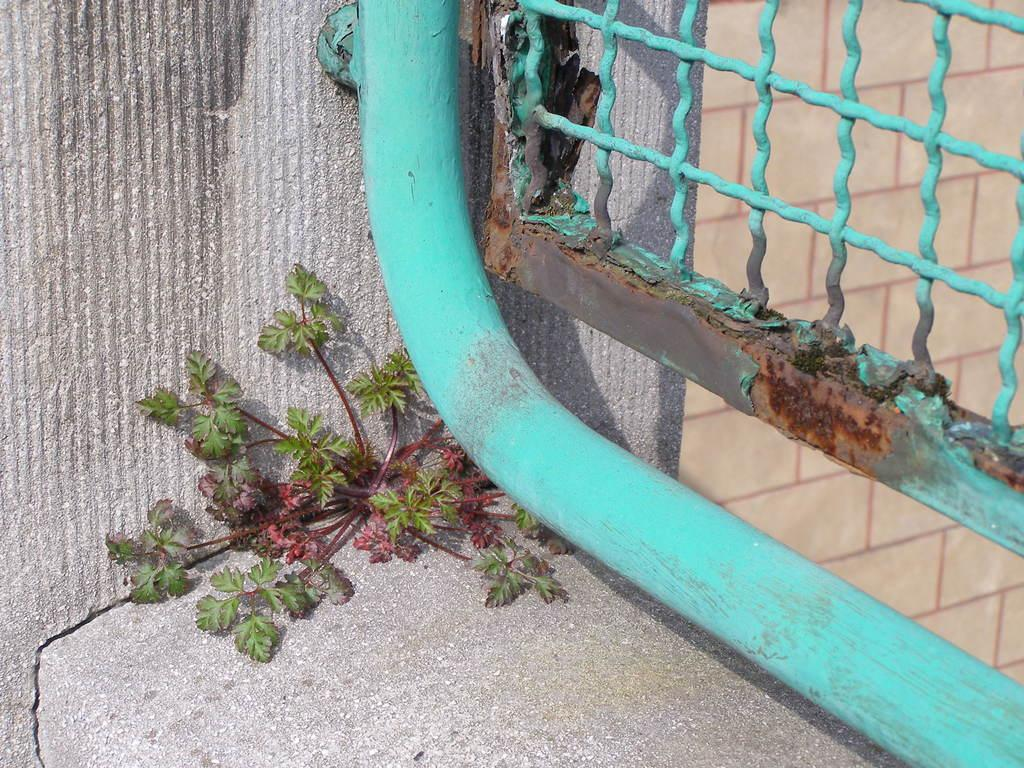What type of living organism can be seen in the image? There is a plant in the image. What material is the fence in the image made of? The fence in the image is made of metal. What type of structure is visible in the image? There is a wall in the image. What type of motion can be observed in the plant in the image? The plant does not exhibit any motion in the image; it is stationary. Can you describe the crowd present in the image? There is no crowd present in the image. 